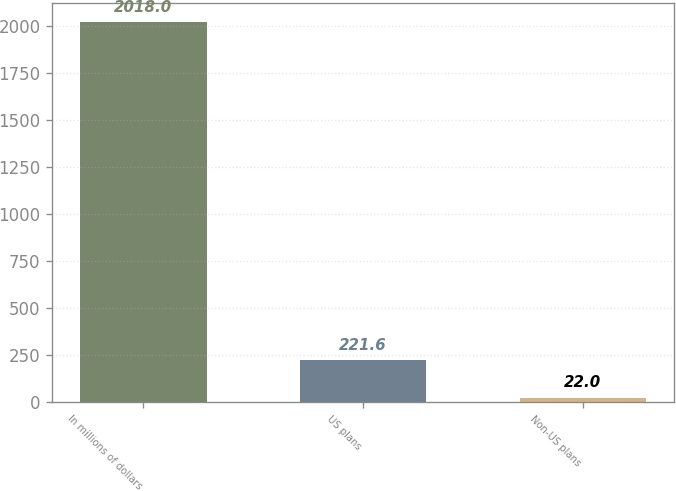<chart> <loc_0><loc_0><loc_500><loc_500><bar_chart><fcel>In millions of dollars<fcel>US plans<fcel>Non-US plans<nl><fcel>2018<fcel>221.6<fcel>22<nl></chart> 